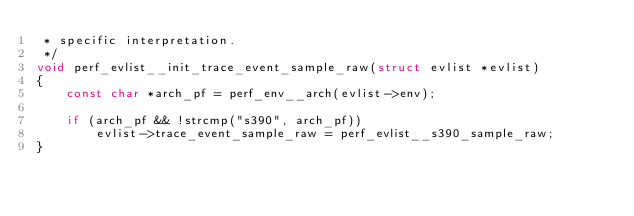<code> <loc_0><loc_0><loc_500><loc_500><_C_> * specific interpretation.
 */
void perf_evlist__init_trace_event_sample_raw(struct evlist *evlist)
{
	const char *arch_pf = perf_env__arch(evlist->env);

	if (arch_pf && !strcmp("s390", arch_pf))
		evlist->trace_event_sample_raw = perf_evlist__s390_sample_raw;
}
</code> 